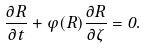Convert formula to latex. <formula><loc_0><loc_0><loc_500><loc_500>\frac { \partial R } { \partial t } + \varphi ( R ) \frac { \partial R } { \partial \zeta } = 0 .</formula> 